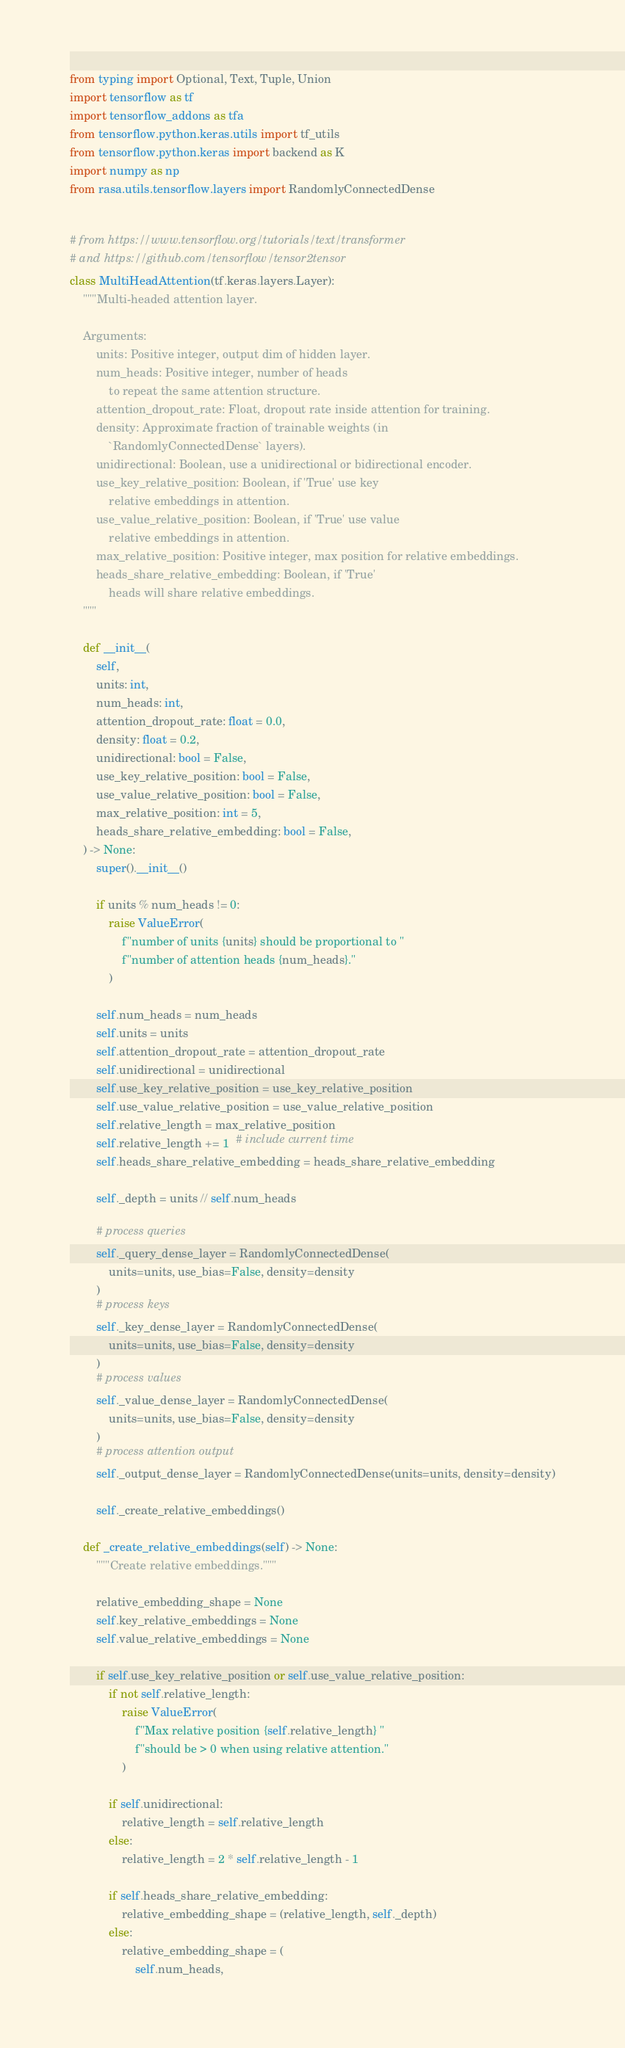<code> <loc_0><loc_0><loc_500><loc_500><_Python_>from typing import Optional, Text, Tuple, Union
import tensorflow as tf
import tensorflow_addons as tfa
from tensorflow.python.keras.utils import tf_utils
from tensorflow.python.keras import backend as K
import numpy as np
from rasa.utils.tensorflow.layers import RandomlyConnectedDense


# from https://www.tensorflow.org/tutorials/text/transformer
# and https://github.com/tensorflow/tensor2tensor
class MultiHeadAttention(tf.keras.layers.Layer):
    """Multi-headed attention layer.

    Arguments:
        units: Positive integer, output dim of hidden layer.
        num_heads: Positive integer, number of heads
            to repeat the same attention structure.
        attention_dropout_rate: Float, dropout rate inside attention for training.
        density: Approximate fraction of trainable weights (in
            `RandomlyConnectedDense` layers).
        unidirectional: Boolean, use a unidirectional or bidirectional encoder.
        use_key_relative_position: Boolean, if 'True' use key
            relative embeddings in attention.
        use_value_relative_position: Boolean, if 'True' use value
            relative embeddings in attention.
        max_relative_position: Positive integer, max position for relative embeddings.
        heads_share_relative_embedding: Boolean, if 'True'
            heads will share relative embeddings.
    """

    def __init__(
        self,
        units: int,
        num_heads: int,
        attention_dropout_rate: float = 0.0,
        density: float = 0.2,
        unidirectional: bool = False,
        use_key_relative_position: bool = False,
        use_value_relative_position: bool = False,
        max_relative_position: int = 5,
        heads_share_relative_embedding: bool = False,
    ) -> None:
        super().__init__()

        if units % num_heads != 0:
            raise ValueError(
                f"number of units {units} should be proportional to "
                f"number of attention heads {num_heads}."
            )

        self.num_heads = num_heads
        self.units = units
        self.attention_dropout_rate = attention_dropout_rate
        self.unidirectional = unidirectional
        self.use_key_relative_position = use_key_relative_position
        self.use_value_relative_position = use_value_relative_position
        self.relative_length = max_relative_position
        self.relative_length += 1  # include current time
        self.heads_share_relative_embedding = heads_share_relative_embedding

        self._depth = units // self.num_heads

        # process queries
        self._query_dense_layer = RandomlyConnectedDense(
            units=units, use_bias=False, density=density
        )
        # process keys
        self._key_dense_layer = RandomlyConnectedDense(
            units=units, use_bias=False, density=density
        )
        # process values
        self._value_dense_layer = RandomlyConnectedDense(
            units=units, use_bias=False, density=density
        )
        # process attention output
        self._output_dense_layer = RandomlyConnectedDense(units=units, density=density)

        self._create_relative_embeddings()

    def _create_relative_embeddings(self) -> None:
        """Create relative embeddings."""

        relative_embedding_shape = None
        self.key_relative_embeddings = None
        self.value_relative_embeddings = None

        if self.use_key_relative_position or self.use_value_relative_position:
            if not self.relative_length:
                raise ValueError(
                    f"Max relative position {self.relative_length} "
                    f"should be > 0 when using relative attention."
                )

            if self.unidirectional:
                relative_length = self.relative_length
            else:
                relative_length = 2 * self.relative_length - 1

            if self.heads_share_relative_embedding:
                relative_embedding_shape = (relative_length, self._depth)
            else:
                relative_embedding_shape = (
                    self.num_heads,</code> 